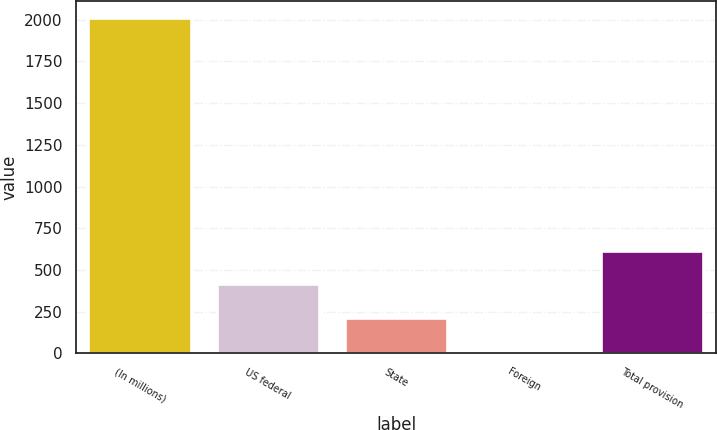<chart> <loc_0><loc_0><loc_500><loc_500><bar_chart><fcel>(In millions)<fcel>US federal<fcel>State<fcel>Foreign<fcel>Total provision<nl><fcel>2010<fcel>413.44<fcel>213.87<fcel>14.3<fcel>613.01<nl></chart> 